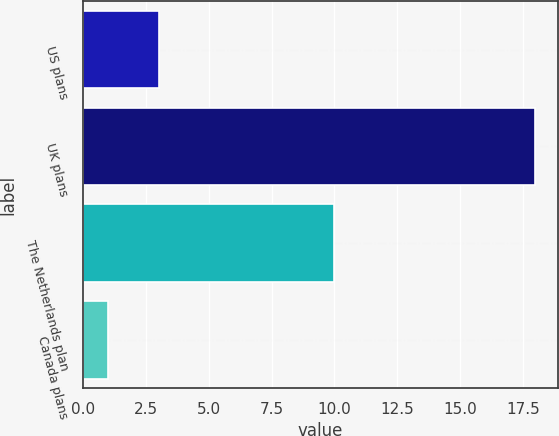Convert chart to OTSL. <chart><loc_0><loc_0><loc_500><loc_500><bar_chart><fcel>US plans<fcel>UK plans<fcel>The Netherlands plan<fcel>Canada plans<nl><fcel>3<fcel>18<fcel>10<fcel>1<nl></chart> 